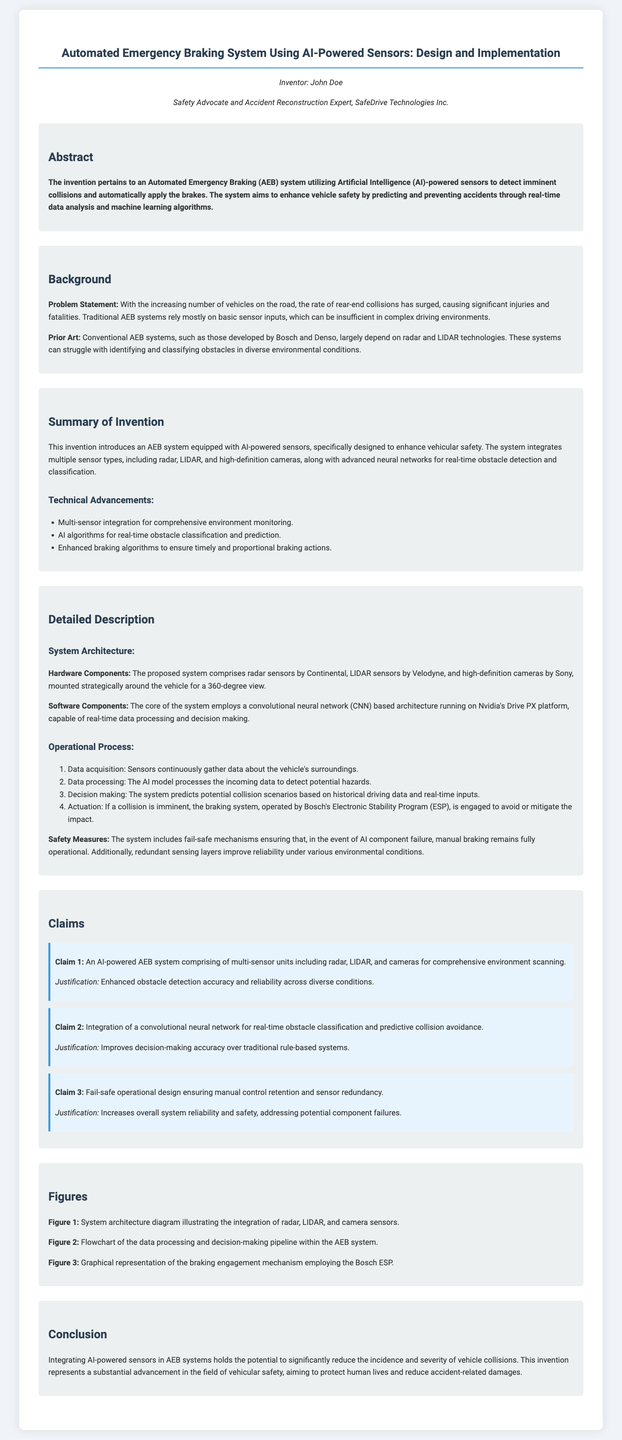What is the title of the patent application? The title appears prominently at the top of the document, summarizing the invention's focus.
Answer: Automated Emergency Braking System Using AI-Powered Sensors: Design and Implementation Who is the inventor of the system? The document specifies the inventor's name in the introduction section.
Answer: John Doe What technology does the AEB system integrate for obstacle detection? The summary section outlines the various technologies integrated into the system.
Answer: Radar, LIDAR, and high-definition cameras What advantage does the AI-powered system provide over conventional AEB systems? The summary highlights the key benefits of the new system compared to traditional methodologies.
Answer: Enhanced obstacle detection accuracy What component is used for data processing in the system? The description specifies the software component that is central to the processing function of the AEB system.
Answer: Convolutional neural network How many claims are made in the patent application? The claims section lists the number of specific points being claimed in the application.
Answer: Three What is the purpose of the fail-safe mechanism? The description clarifies why the fail-safe measures are incorporated into the system architecture.
Answer: Ensuring manual control retention Which company developed the Electronic Stability Program mentioned in the system? The document mentions this in the operational process section regarding the braking engagement mechanism.
Answer: Bosch What is the goal of the invention according to the conclusion? The conclusion summarizes the primary aim of the development of the AEB system.
Answer: To significantly reduce the incidence and severity of vehicle collisions 